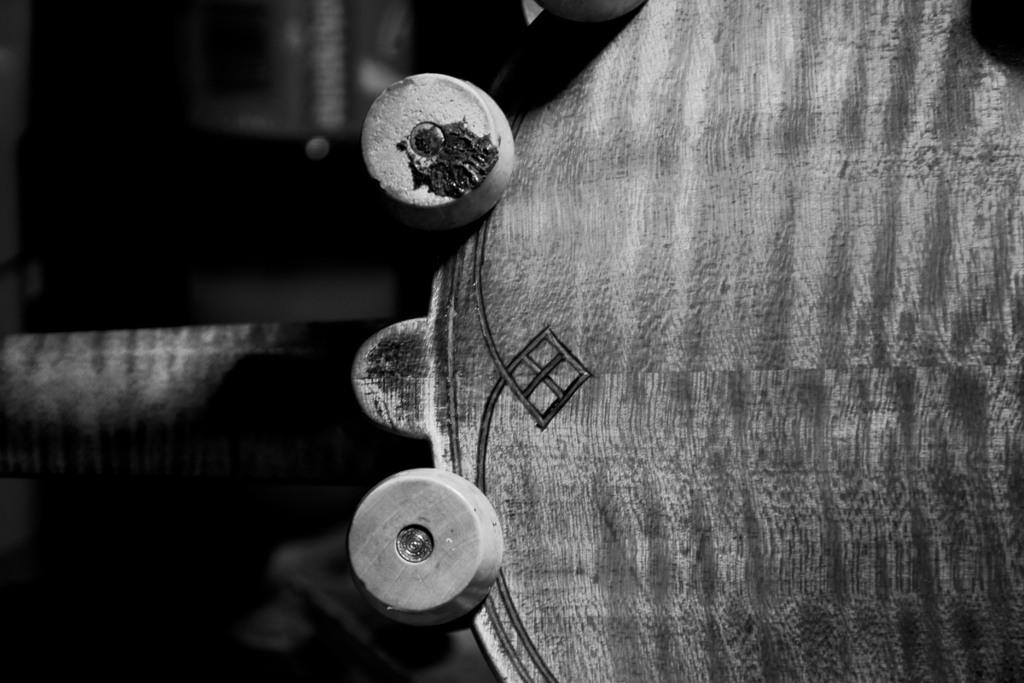What is the color scheme of the image? The image is black and white. What can be seen attached to the wood in the image? There are bolts attached to the wood in the image. How would you describe the background of the image? The background of the image is blurred. What type of polish is being applied to the wood in the image? There is no polish being applied to the wood in the image; it only shows bolts attached to the wood. How many kisses can be seen on the wood in the image? There are no kisses present in the image. 